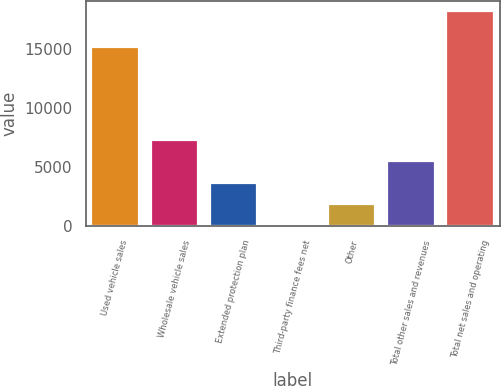Convert chart to OTSL. <chart><loc_0><loc_0><loc_500><loc_500><bar_chart><fcel>Used vehicle sales<fcel>Wholesale vehicle sales<fcel>Extended protection plan<fcel>Third-party finance fees net<fcel>Other<fcel>Total other sales and revenues<fcel>Total net sales and operating<nl><fcel>15172.8<fcel>7295.28<fcel>3669.34<fcel>43.4<fcel>1856.37<fcel>5482.31<fcel>18173.1<nl></chart> 